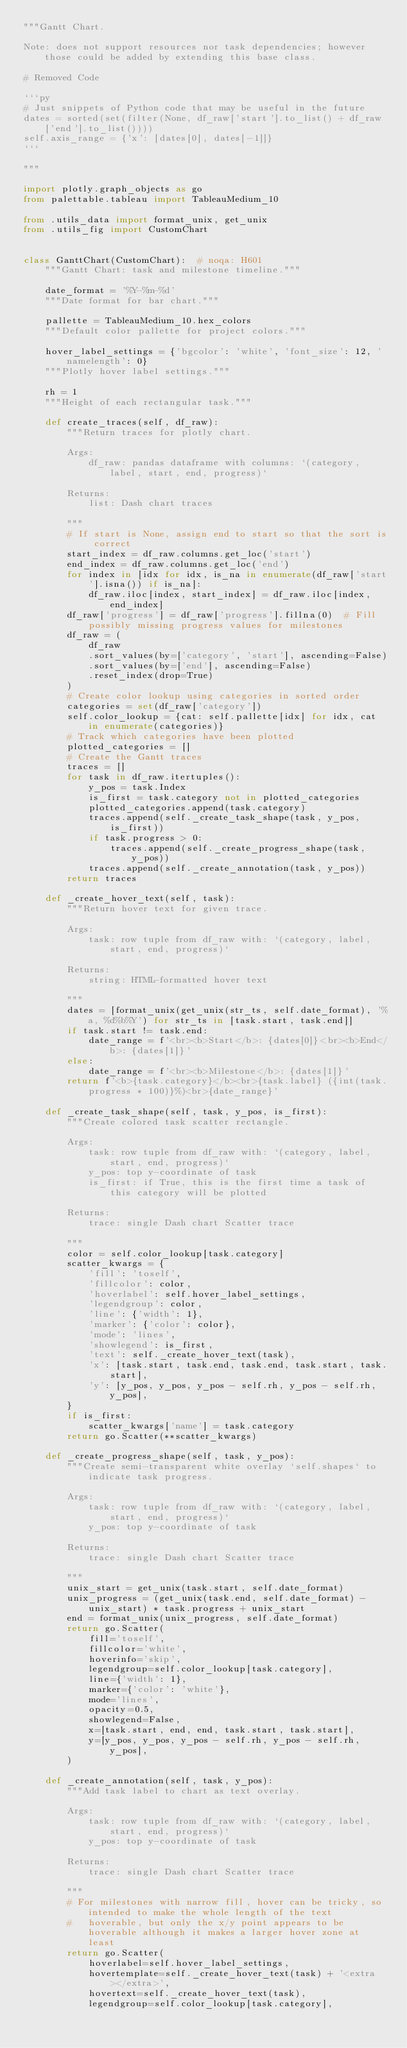<code> <loc_0><loc_0><loc_500><loc_500><_Python_>"""Gantt Chart.

Note: does not support resources nor task dependencies; however those could be added by extending this base class.

# Removed Code

```py
# Just snippets of Python code that may be useful in the future
dates = sorted(set(filter(None, df_raw['start'].to_list() + df_raw['end'].to_list())))
self.axis_range = {'x': [dates[0], dates[-1]]}
```

"""

import plotly.graph_objects as go
from palettable.tableau import TableauMedium_10

from .utils_data import format_unix, get_unix
from .utils_fig import CustomChart


class GanttChart(CustomChart):  # noqa: H601
    """Gantt Chart: task and milestone timeline."""

    date_format = '%Y-%m-%d'
    """Date format for bar chart."""

    pallette = TableauMedium_10.hex_colors
    """Default color pallette for project colors."""

    hover_label_settings = {'bgcolor': 'white', 'font_size': 12, 'namelength': 0}
    """Plotly hover label settings."""

    rh = 1
    """Height of each rectangular task."""

    def create_traces(self, df_raw):
        """Return traces for plotly chart.

        Args:
            df_raw: pandas dataframe with columns: `(category, label, start, end, progress)`

        Returns:
            list: Dash chart traces

        """
        # If start is None, assign end to start so that the sort is correct
        start_index = df_raw.columns.get_loc('start')
        end_index = df_raw.columns.get_loc('end')
        for index in [idx for idx, is_na in enumerate(df_raw['start'].isna()) if is_na]:
            df_raw.iloc[index, start_index] = df_raw.iloc[index, end_index]
        df_raw['progress'] = df_raw['progress'].fillna(0)  # Fill possibly missing progress values for milestones
        df_raw = (
            df_raw
            .sort_values(by=['category', 'start'], ascending=False)
            .sort_values(by=['end'], ascending=False)
            .reset_index(drop=True)
        )
        # Create color lookup using categories in sorted order
        categories = set(df_raw['category'])
        self.color_lookup = {cat: self.pallette[idx] for idx, cat in enumerate(categories)}
        # Track which categories have been plotted
        plotted_categories = []
        # Create the Gantt traces
        traces = []
        for task in df_raw.itertuples():
            y_pos = task.Index
            is_first = task.category not in plotted_categories
            plotted_categories.append(task.category)
            traces.append(self._create_task_shape(task, y_pos, is_first))
            if task.progress > 0:
                traces.append(self._create_progress_shape(task, y_pos))
            traces.append(self._create_annotation(task, y_pos))
        return traces

    def _create_hover_text(self, task):
        """Return hover text for given trace.

        Args:
            task: row tuple from df_raw with: `(category, label, start, end, progress)`

        Returns:
            string: HTML-formatted hover text

        """
        dates = [format_unix(get_unix(str_ts, self.date_format), '%a, %d%b%Y') for str_ts in [task.start, task.end]]
        if task.start != task.end:
            date_range = f'<br><b>Start</b>: {dates[0]}<br><b>End</b>: {dates[1]}'
        else:
            date_range = f'<br><b>Milestone</b>: {dates[1]}'
        return f'<b>{task.category}</b><br>{task.label} ({int(task.progress * 100)}%)<br>{date_range}'

    def _create_task_shape(self, task, y_pos, is_first):
        """Create colored task scatter rectangle.

        Args:
            task: row tuple from df_raw with: `(category, label, start, end, progress)`
            y_pos: top y-coordinate of task
            is_first: if True, this is the first time a task of this category will be plotted

        Returns:
            trace: single Dash chart Scatter trace

        """
        color = self.color_lookup[task.category]
        scatter_kwargs = {
            'fill': 'toself',
            'fillcolor': color,
            'hoverlabel': self.hover_label_settings,
            'legendgroup': color,
            'line': {'width': 1},
            'marker': {'color': color},
            'mode': 'lines',
            'showlegend': is_first,
            'text': self._create_hover_text(task),
            'x': [task.start, task.end, task.end, task.start, task.start],
            'y': [y_pos, y_pos, y_pos - self.rh, y_pos - self.rh, y_pos],
        }
        if is_first:
            scatter_kwargs['name'] = task.category
        return go.Scatter(**scatter_kwargs)

    def _create_progress_shape(self, task, y_pos):
        """Create semi-transparent white overlay `self.shapes` to indicate task progress.

        Args:
            task: row tuple from df_raw with: `(category, label, start, end, progress)`
            y_pos: top y-coordinate of task

        Returns:
            trace: single Dash chart Scatter trace

        """
        unix_start = get_unix(task.start, self.date_format)
        unix_progress = (get_unix(task.end, self.date_format) - unix_start) * task.progress + unix_start
        end = format_unix(unix_progress, self.date_format)
        return go.Scatter(
            fill='toself',
            fillcolor='white',
            hoverinfo='skip',
            legendgroup=self.color_lookup[task.category],
            line={'width': 1},
            marker={'color': 'white'},
            mode='lines',
            opacity=0.5,
            showlegend=False,
            x=[task.start, end, end, task.start, task.start],
            y=[y_pos, y_pos, y_pos - self.rh, y_pos - self.rh, y_pos],
        )

    def _create_annotation(self, task, y_pos):
        """Add task label to chart as text overlay.

        Args:
            task: row tuple from df_raw with: `(category, label, start, end, progress)`
            y_pos: top y-coordinate of task

        Returns:
            trace: single Dash chart Scatter trace

        """
        # For milestones with narrow fill, hover can be tricky, so intended to make the whole length of the text
        #   hoverable, but only the x/y point appears to be hoverable although it makes a larger hover zone at least
        return go.Scatter(
            hoverlabel=self.hover_label_settings,
            hovertemplate=self._create_hover_text(task) + '<extra></extra>',
            hovertext=self._create_hover_text(task),
            legendgroup=self.color_lookup[task.category],</code> 